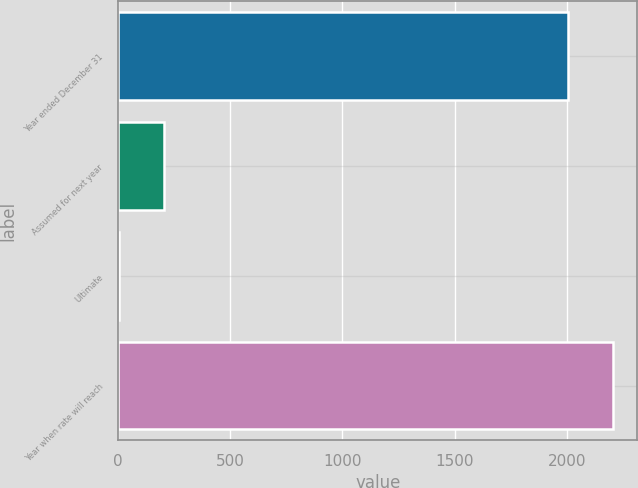Convert chart. <chart><loc_0><loc_0><loc_500><loc_500><bar_chart><fcel>Year ended December 31<fcel>Assumed for next year<fcel>Ultimate<fcel>Year when rate will reach<nl><fcel>2005<fcel>204.6<fcel>4<fcel>2205.6<nl></chart> 